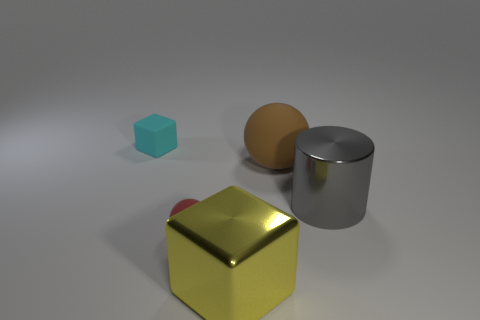How does the lighting affect the appearance of each object? The lighting in the image creates soft shadows and subtle reflections, highlighting the texture and material properties of the objects. It gives the scene a three-dimensional feel and emphasizes the metallic surface of the cylinder and the glossy finish of the sphere compared to the more diffused light on the matte surfaces. 